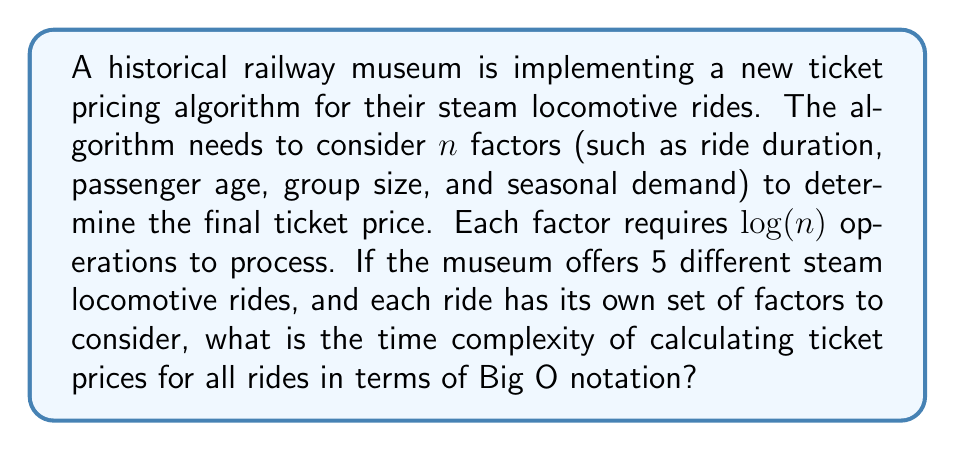Can you solve this math problem? Let's break this problem down step by step:

1) For each individual ride, the algorithm needs to consider $n$ factors.

2) Each factor requires $\log(n)$ operations to process.

3) Therefore, for a single ride, the time complexity is:
   $$ n \cdot \log(n) $$

4) The museum offers 5 different steam locomotive rides, each with its own set of factors.

5) Since we're performing the same operation (calculating ticket price) for each of the 5 rides, we multiply the time complexity of a single ride by 5:
   $$ 5 \cdot (n \cdot \log(n)) $$

6) In Big O notation, we drop constant factors. Therefore, the 5 can be removed:
   $$ O(n \log n) $$

7) This simplification is valid because Big O notation describes the upper bound of the growth rate of the function, and constant factors don't affect this growth rate in the long run.

Thus, the overall time complexity for calculating ticket prices for all rides is $O(n \log n)$.
Answer: $O(n \log n)$ 